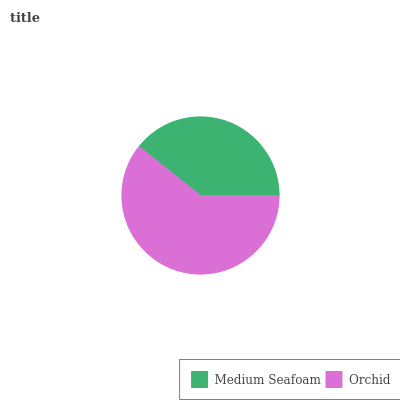Is Medium Seafoam the minimum?
Answer yes or no. Yes. Is Orchid the maximum?
Answer yes or no. Yes. Is Orchid the minimum?
Answer yes or no. No. Is Orchid greater than Medium Seafoam?
Answer yes or no. Yes. Is Medium Seafoam less than Orchid?
Answer yes or no. Yes. Is Medium Seafoam greater than Orchid?
Answer yes or no. No. Is Orchid less than Medium Seafoam?
Answer yes or no. No. Is Orchid the high median?
Answer yes or no. Yes. Is Medium Seafoam the low median?
Answer yes or no. Yes. Is Medium Seafoam the high median?
Answer yes or no. No. Is Orchid the low median?
Answer yes or no. No. 